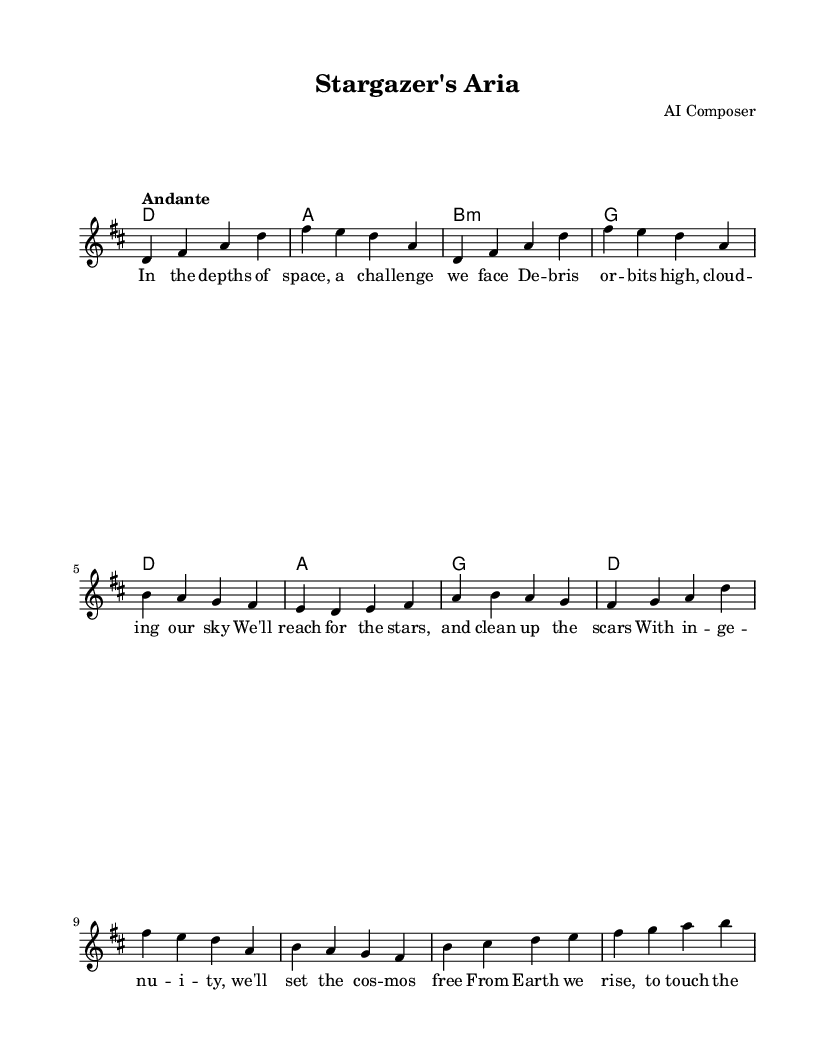What is the key signature of this music? The key signature is D major, which has two sharps: F# and C#.
Answer: D major What is the time signature? The time signature is 4/4, indicating four beats per measure.
Answer: 4/4 What is the tempo marking? The tempo marking is "Andante," which suggests a moderately slow pace.
Answer: Andante How many vocal lines are present in the score? There is one vocal line presented, indicated by the "melody" voice in the staff.
Answer: One What is the structure of the song? The song consists of an introduction, verse, chorus, and bridge, highlighting the typical operatic form.
Answer: Introduction, Verse, Chorus, Bridge What is the primary theme of the lyrics? The primary theme of the lyrics revolves around space debris and human ingenuity in overcoming challenges.
Answer: Space debris and ingenuity How does the melody respond to the text's emotional tone? The melody ascends and descends, reflecting a hopeful and determined emotional tone that matches the lyrics about innovation and reaching for the stars.
Answer: Hopeful and determined 